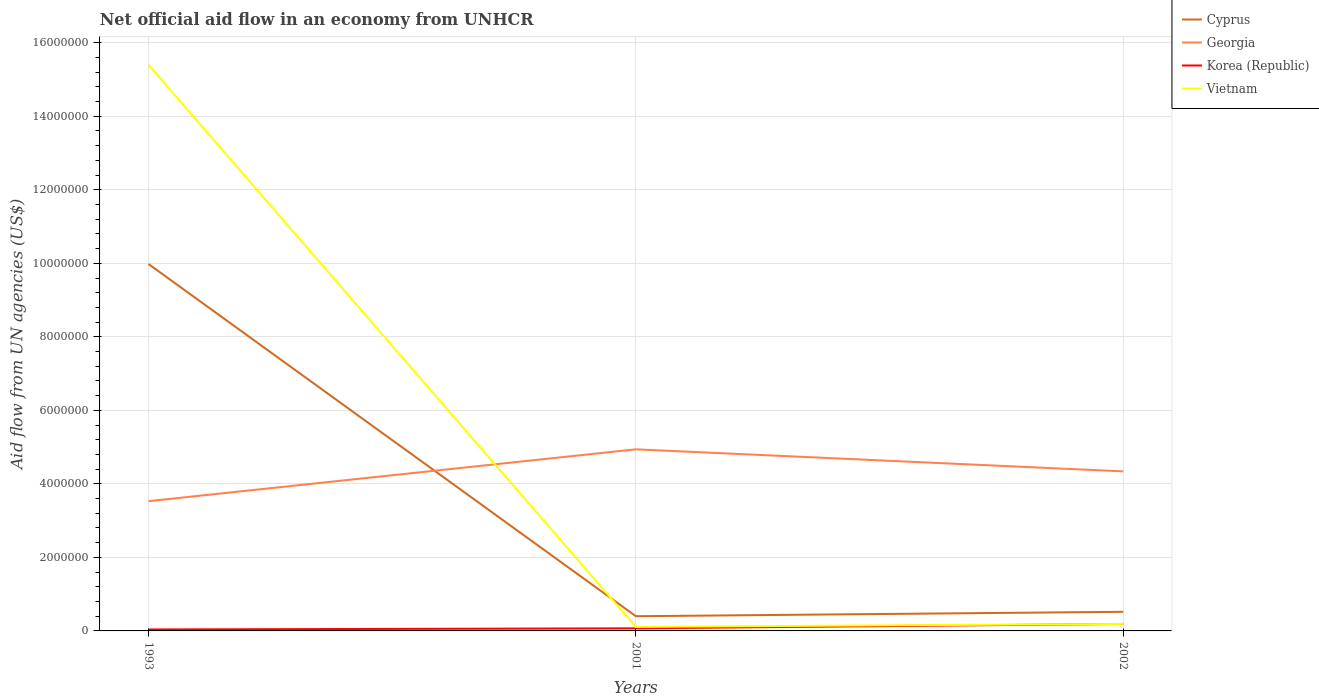How many different coloured lines are there?
Your response must be concise. 4. Across all years, what is the maximum net official aid flow in Vietnam?
Your answer should be very brief. 1.10e+05. What is the total net official aid flow in Cyprus in the graph?
Offer a very short reply. 9.58e+06. What is the difference between the highest and the second highest net official aid flow in Georgia?
Your answer should be very brief. 1.41e+06. What is the difference between the highest and the lowest net official aid flow in Cyprus?
Provide a succinct answer. 1. Is the net official aid flow in Cyprus strictly greater than the net official aid flow in Georgia over the years?
Offer a very short reply. No. What is the difference between two consecutive major ticks on the Y-axis?
Ensure brevity in your answer.  2.00e+06. Does the graph contain any zero values?
Provide a succinct answer. No. Does the graph contain grids?
Your response must be concise. Yes. Where does the legend appear in the graph?
Provide a short and direct response. Top right. How many legend labels are there?
Provide a succinct answer. 4. How are the legend labels stacked?
Offer a terse response. Vertical. What is the title of the graph?
Offer a very short reply. Net official aid flow in an economy from UNHCR. What is the label or title of the Y-axis?
Provide a succinct answer. Aid flow from UN agencies (US$). What is the Aid flow from UN agencies (US$) of Cyprus in 1993?
Ensure brevity in your answer.  9.98e+06. What is the Aid flow from UN agencies (US$) of Georgia in 1993?
Your response must be concise. 3.53e+06. What is the Aid flow from UN agencies (US$) of Vietnam in 1993?
Provide a short and direct response. 1.54e+07. What is the Aid flow from UN agencies (US$) of Georgia in 2001?
Your answer should be compact. 4.94e+06. What is the Aid flow from UN agencies (US$) in Cyprus in 2002?
Provide a short and direct response. 5.20e+05. What is the Aid flow from UN agencies (US$) in Georgia in 2002?
Provide a succinct answer. 4.34e+06. What is the Aid flow from UN agencies (US$) in Korea (Republic) in 2002?
Keep it short and to the point. 1.90e+05. Across all years, what is the maximum Aid flow from UN agencies (US$) in Cyprus?
Provide a succinct answer. 9.98e+06. Across all years, what is the maximum Aid flow from UN agencies (US$) of Georgia?
Your answer should be compact. 4.94e+06. Across all years, what is the maximum Aid flow from UN agencies (US$) in Vietnam?
Offer a terse response. 1.54e+07. Across all years, what is the minimum Aid flow from UN agencies (US$) of Georgia?
Keep it short and to the point. 3.53e+06. Across all years, what is the minimum Aid flow from UN agencies (US$) of Vietnam?
Your answer should be compact. 1.10e+05. What is the total Aid flow from UN agencies (US$) in Cyprus in the graph?
Offer a terse response. 1.09e+07. What is the total Aid flow from UN agencies (US$) in Georgia in the graph?
Make the answer very short. 1.28e+07. What is the total Aid flow from UN agencies (US$) of Korea (Republic) in the graph?
Offer a very short reply. 3.00e+05. What is the total Aid flow from UN agencies (US$) in Vietnam in the graph?
Provide a short and direct response. 1.57e+07. What is the difference between the Aid flow from UN agencies (US$) of Cyprus in 1993 and that in 2001?
Offer a very short reply. 9.58e+06. What is the difference between the Aid flow from UN agencies (US$) of Georgia in 1993 and that in 2001?
Your answer should be compact. -1.41e+06. What is the difference between the Aid flow from UN agencies (US$) of Korea (Republic) in 1993 and that in 2001?
Provide a succinct answer. -3.00e+04. What is the difference between the Aid flow from UN agencies (US$) of Vietnam in 1993 and that in 2001?
Provide a short and direct response. 1.53e+07. What is the difference between the Aid flow from UN agencies (US$) of Cyprus in 1993 and that in 2002?
Your answer should be compact. 9.46e+06. What is the difference between the Aid flow from UN agencies (US$) in Georgia in 1993 and that in 2002?
Your answer should be very brief. -8.10e+05. What is the difference between the Aid flow from UN agencies (US$) in Vietnam in 1993 and that in 2002?
Offer a very short reply. 1.52e+07. What is the difference between the Aid flow from UN agencies (US$) in Cyprus in 2001 and that in 2002?
Keep it short and to the point. -1.20e+05. What is the difference between the Aid flow from UN agencies (US$) of Korea (Republic) in 2001 and that in 2002?
Provide a short and direct response. -1.20e+05. What is the difference between the Aid flow from UN agencies (US$) in Cyprus in 1993 and the Aid flow from UN agencies (US$) in Georgia in 2001?
Provide a succinct answer. 5.04e+06. What is the difference between the Aid flow from UN agencies (US$) of Cyprus in 1993 and the Aid flow from UN agencies (US$) of Korea (Republic) in 2001?
Provide a succinct answer. 9.91e+06. What is the difference between the Aid flow from UN agencies (US$) of Cyprus in 1993 and the Aid flow from UN agencies (US$) of Vietnam in 2001?
Give a very brief answer. 9.87e+06. What is the difference between the Aid flow from UN agencies (US$) of Georgia in 1993 and the Aid flow from UN agencies (US$) of Korea (Republic) in 2001?
Your answer should be compact. 3.46e+06. What is the difference between the Aid flow from UN agencies (US$) in Georgia in 1993 and the Aid flow from UN agencies (US$) in Vietnam in 2001?
Keep it short and to the point. 3.42e+06. What is the difference between the Aid flow from UN agencies (US$) of Korea (Republic) in 1993 and the Aid flow from UN agencies (US$) of Vietnam in 2001?
Offer a terse response. -7.00e+04. What is the difference between the Aid flow from UN agencies (US$) in Cyprus in 1993 and the Aid flow from UN agencies (US$) in Georgia in 2002?
Give a very brief answer. 5.64e+06. What is the difference between the Aid flow from UN agencies (US$) in Cyprus in 1993 and the Aid flow from UN agencies (US$) in Korea (Republic) in 2002?
Your answer should be very brief. 9.79e+06. What is the difference between the Aid flow from UN agencies (US$) in Cyprus in 1993 and the Aid flow from UN agencies (US$) in Vietnam in 2002?
Provide a short and direct response. 9.79e+06. What is the difference between the Aid flow from UN agencies (US$) in Georgia in 1993 and the Aid flow from UN agencies (US$) in Korea (Republic) in 2002?
Keep it short and to the point. 3.34e+06. What is the difference between the Aid flow from UN agencies (US$) in Georgia in 1993 and the Aid flow from UN agencies (US$) in Vietnam in 2002?
Your answer should be compact. 3.34e+06. What is the difference between the Aid flow from UN agencies (US$) in Korea (Republic) in 1993 and the Aid flow from UN agencies (US$) in Vietnam in 2002?
Your answer should be very brief. -1.50e+05. What is the difference between the Aid flow from UN agencies (US$) of Cyprus in 2001 and the Aid flow from UN agencies (US$) of Georgia in 2002?
Offer a very short reply. -3.94e+06. What is the difference between the Aid flow from UN agencies (US$) in Georgia in 2001 and the Aid flow from UN agencies (US$) in Korea (Republic) in 2002?
Provide a short and direct response. 4.75e+06. What is the difference between the Aid flow from UN agencies (US$) of Georgia in 2001 and the Aid flow from UN agencies (US$) of Vietnam in 2002?
Your answer should be very brief. 4.75e+06. What is the difference between the Aid flow from UN agencies (US$) in Korea (Republic) in 2001 and the Aid flow from UN agencies (US$) in Vietnam in 2002?
Provide a short and direct response. -1.20e+05. What is the average Aid flow from UN agencies (US$) of Cyprus per year?
Give a very brief answer. 3.63e+06. What is the average Aid flow from UN agencies (US$) in Georgia per year?
Give a very brief answer. 4.27e+06. What is the average Aid flow from UN agencies (US$) of Vietnam per year?
Your response must be concise. 5.23e+06. In the year 1993, what is the difference between the Aid flow from UN agencies (US$) in Cyprus and Aid flow from UN agencies (US$) in Georgia?
Offer a very short reply. 6.45e+06. In the year 1993, what is the difference between the Aid flow from UN agencies (US$) in Cyprus and Aid flow from UN agencies (US$) in Korea (Republic)?
Offer a terse response. 9.94e+06. In the year 1993, what is the difference between the Aid flow from UN agencies (US$) in Cyprus and Aid flow from UN agencies (US$) in Vietnam?
Offer a very short reply. -5.42e+06. In the year 1993, what is the difference between the Aid flow from UN agencies (US$) of Georgia and Aid flow from UN agencies (US$) of Korea (Republic)?
Ensure brevity in your answer.  3.49e+06. In the year 1993, what is the difference between the Aid flow from UN agencies (US$) in Georgia and Aid flow from UN agencies (US$) in Vietnam?
Offer a very short reply. -1.19e+07. In the year 1993, what is the difference between the Aid flow from UN agencies (US$) in Korea (Republic) and Aid flow from UN agencies (US$) in Vietnam?
Your answer should be very brief. -1.54e+07. In the year 2001, what is the difference between the Aid flow from UN agencies (US$) of Cyprus and Aid flow from UN agencies (US$) of Georgia?
Provide a short and direct response. -4.54e+06. In the year 2001, what is the difference between the Aid flow from UN agencies (US$) of Georgia and Aid flow from UN agencies (US$) of Korea (Republic)?
Offer a very short reply. 4.87e+06. In the year 2001, what is the difference between the Aid flow from UN agencies (US$) in Georgia and Aid flow from UN agencies (US$) in Vietnam?
Give a very brief answer. 4.83e+06. In the year 2001, what is the difference between the Aid flow from UN agencies (US$) of Korea (Republic) and Aid flow from UN agencies (US$) of Vietnam?
Keep it short and to the point. -4.00e+04. In the year 2002, what is the difference between the Aid flow from UN agencies (US$) of Cyprus and Aid flow from UN agencies (US$) of Georgia?
Give a very brief answer. -3.82e+06. In the year 2002, what is the difference between the Aid flow from UN agencies (US$) in Cyprus and Aid flow from UN agencies (US$) in Korea (Republic)?
Provide a short and direct response. 3.30e+05. In the year 2002, what is the difference between the Aid flow from UN agencies (US$) in Georgia and Aid flow from UN agencies (US$) in Korea (Republic)?
Ensure brevity in your answer.  4.15e+06. In the year 2002, what is the difference between the Aid flow from UN agencies (US$) in Georgia and Aid flow from UN agencies (US$) in Vietnam?
Provide a short and direct response. 4.15e+06. What is the ratio of the Aid flow from UN agencies (US$) in Cyprus in 1993 to that in 2001?
Ensure brevity in your answer.  24.95. What is the ratio of the Aid flow from UN agencies (US$) in Georgia in 1993 to that in 2001?
Ensure brevity in your answer.  0.71. What is the ratio of the Aid flow from UN agencies (US$) of Vietnam in 1993 to that in 2001?
Offer a terse response. 140. What is the ratio of the Aid flow from UN agencies (US$) of Cyprus in 1993 to that in 2002?
Offer a terse response. 19.19. What is the ratio of the Aid flow from UN agencies (US$) of Georgia in 1993 to that in 2002?
Make the answer very short. 0.81. What is the ratio of the Aid flow from UN agencies (US$) in Korea (Republic) in 1993 to that in 2002?
Offer a very short reply. 0.21. What is the ratio of the Aid flow from UN agencies (US$) in Vietnam in 1993 to that in 2002?
Your response must be concise. 81.05. What is the ratio of the Aid flow from UN agencies (US$) of Cyprus in 2001 to that in 2002?
Give a very brief answer. 0.77. What is the ratio of the Aid flow from UN agencies (US$) in Georgia in 2001 to that in 2002?
Keep it short and to the point. 1.14. What is the ratio of the Aid flow from UN agencies (US$) of Korea (Republic) in 2001 to that in 2002?
Ensure brevity in your answer.  0.37. What is the ratio of the Aid flow from UN agencies (US$) of Vietnam in 2001 to that in 2002?
Your response must be concise. 0.58. What is the difference between the highest and the second highest Aid flow from UN agencies (US$) in Cyprus?
Keep it short and to the point. 9.46e+06. What is the difference between the highest and the second highest Aid flow from UN agencies (US$) in Vietnam?
Provide a succinct answer. 1.52e+07. What is the difference between the highest and the lowest Aid flow from UN agencies (US$) in Cyprus?
Ensure brevity in your answer.  9.58e+06. What is the difference between the highest and the lowest Aid flow from UN agencies (US$) of Georgia?
Keep it short and to the point. 1.41e+06. What is the difference between the highest and the lowest Aid flow from UN agencies (US$) in Vietnam?
Offer a very short reply. 1.53e+07. 